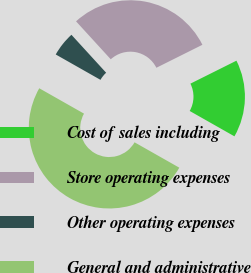<chart> <loc_0><loc_0><loc_500><loc_500><pie_chart><fcel>Cost of sales including<fcel>Store operating expenses<fcel>Other operating expenses<fcel>General and administrative<nl><fcel>15.58%<fcel>29.42%<fcel>5.0%<fcel>50.0%<nl></chart> 